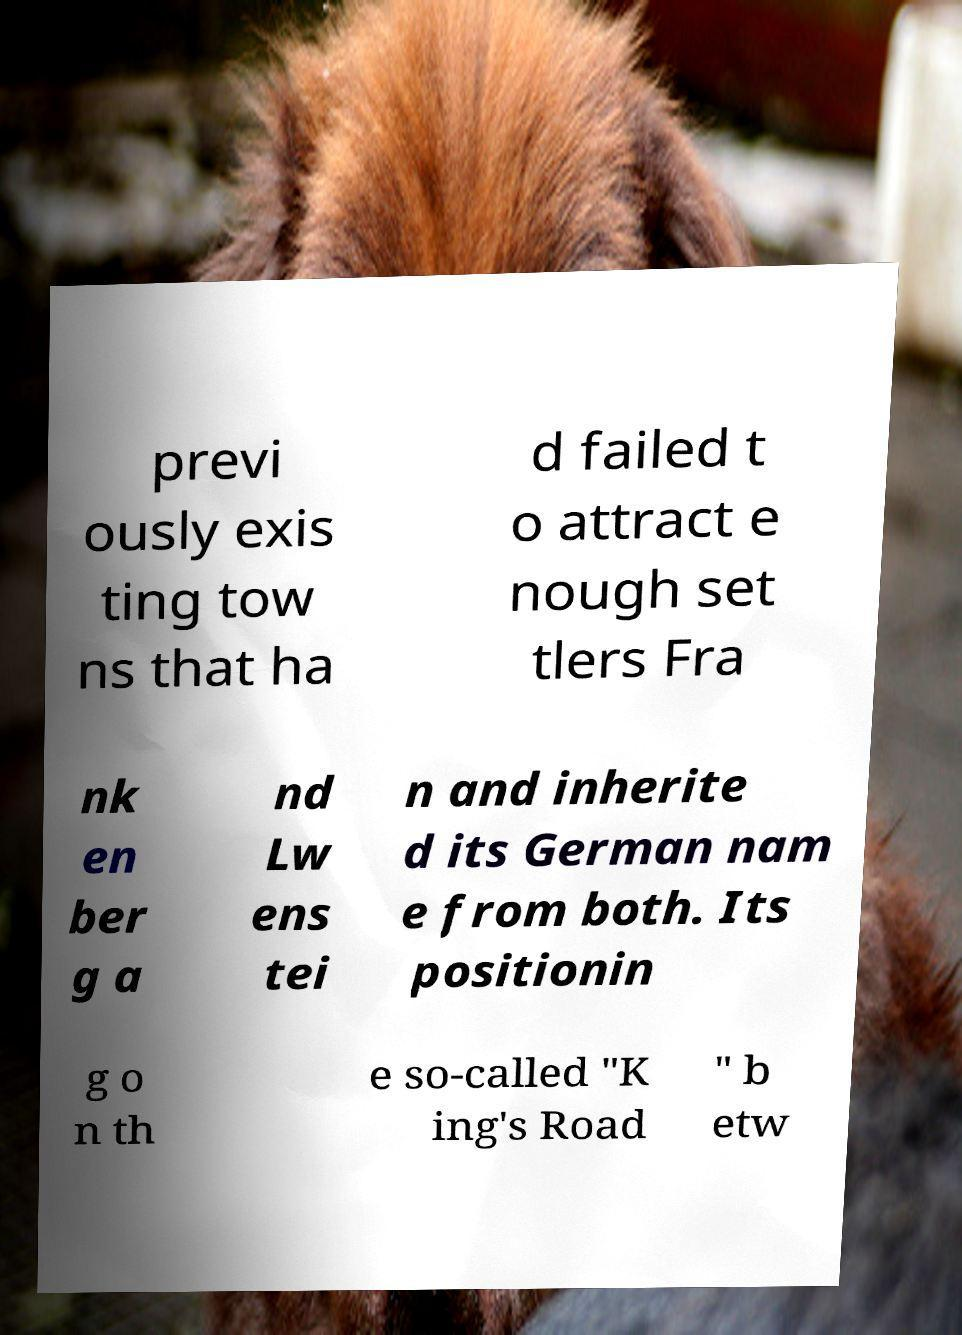Please identify and transcribe the text found in this image. previ ously exis ting tow ns that ha d failed t o attract e nough set tlers Fra nk en ber g a nd Lw ens tei n and inherite d its German nam e from both. Its positionin g o n th e so-called "K ing's Road " b etw 